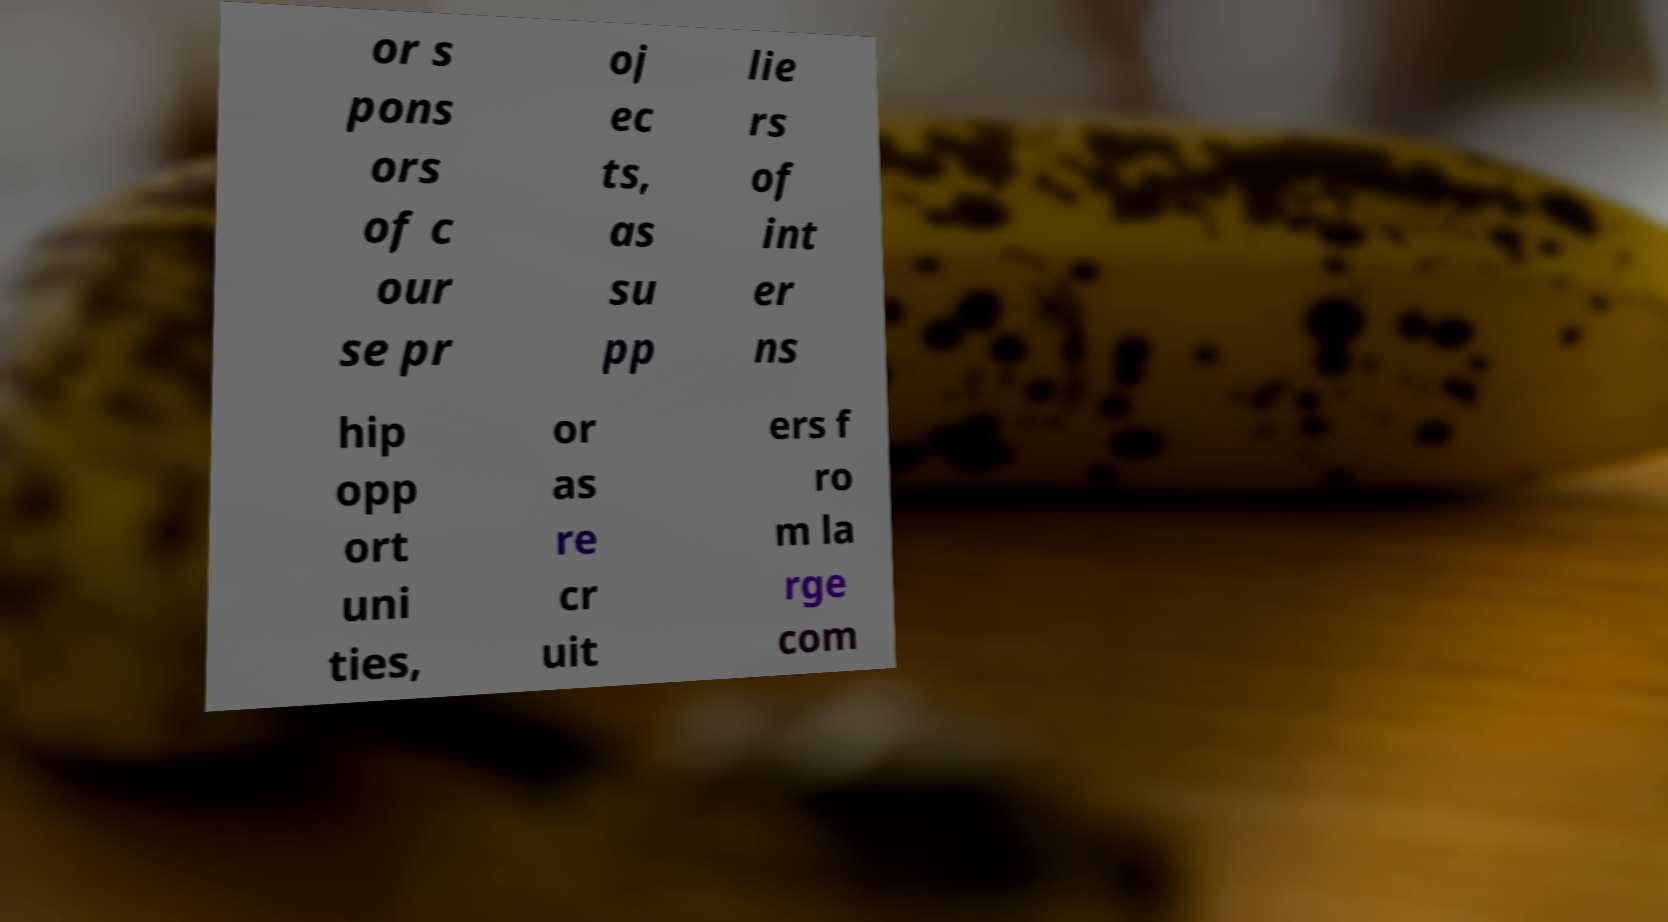Could you assist in decoding the text presented in this image and type it out clearly? or s pons ors of c our se pr oj ec ts, as su pp lie rs of int er ns hip opp ort uni ties, or as re cr uit ers f ro m la rge com 